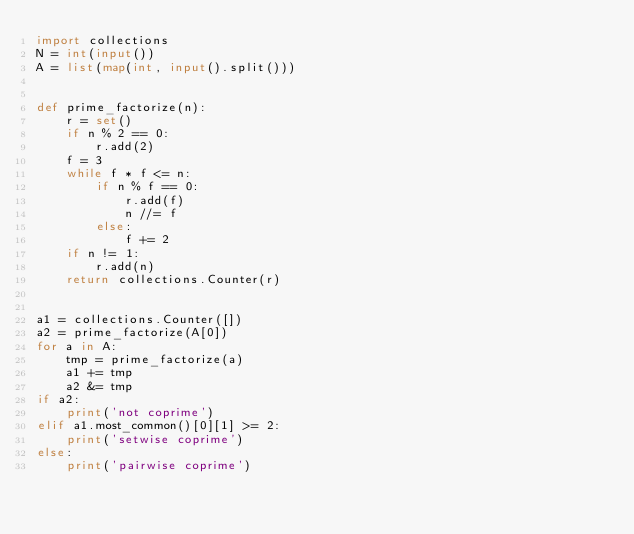Convert code to text. <code><loc_0><loc_0><loc_500><loc_500><_Python_>import collections
N = int(input())
A = list(map(int, input().split()))


def prime_factorize(n):
    r = set()
    if n % 2 == 0:
        r.add(2)
    f = 3
    while f * f <= n:
        if n % f == 0:
            r.add(f)
            n //= f
        else:
            f += 2
    if n != 1:
        r.add(n)
    return collections.Counter(r)


a1 = collections.Counter([])
a2 = prime_factorize(A[0])
for a in A:
    tmp = prime_factorize(a)
    a1 += tmp
    a2 &= tmp
if a2:
    print('not coprime')
elif a1.most_common()[0][1] >= 2:
    print('setwise coprime')
else:
    print('pairwise coprime')</code> 